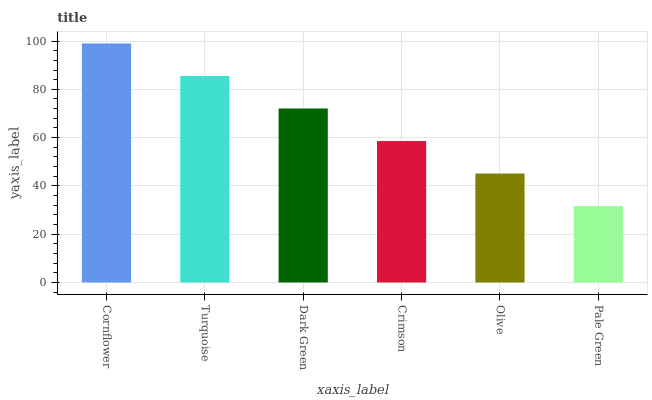Is Pale Green the minimum?
Answer yes or no. Yes. Is Cornflower the maximum?
Answer yes or no. Yes. Is Turquoise the minimum?
Answer yes or no. No. Is Turquoise the maximum?
Answer yes or no. No. Is Cornflower greater than Turquoise?
Answer yes or no. Yes. Is Turquoise less than Cornflower?
Answer yes or no. Yes. Is Turquoise greater than Cornflower?
Answer yes or no. No. Is Cornflower less than Turquoise?
Answer yes or no. No. Is Dark Green the high median?
Answer yes or no. Yes. Is Crimson the low median?
Answer yes or no. Yes. Is Olive the high median?
Answer yes or no. No. Is Cornflower the low median?
Answer yes or no. No. 